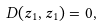<formula> <loc_0><loc_0><loc_500><loc_500>D ( z _ { 1 } , z _ { 1 } ) = 0 ,</formula> 